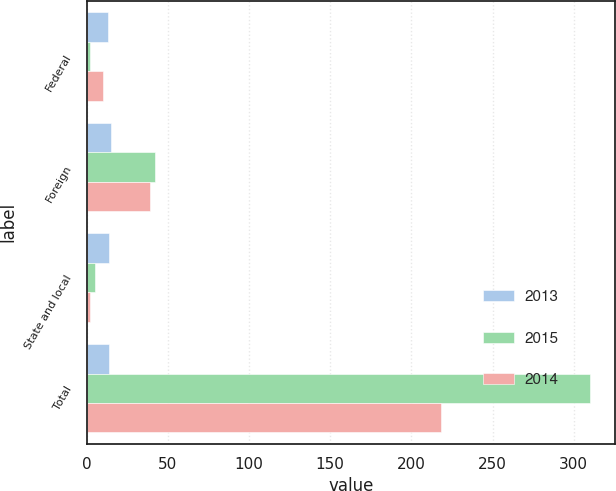<chart> <loc_0><loc_0><loc_500><loc_500><stacked_bar_chart><ecel><fcel>Federal<fcel>Foreign<fcel>State and local<fcel>Total<nl><fcel>2013<fcel>13<fcel>15<fcel>14<fcel>14<nl><fcel>2015<fcel>2<fcel>42<fcel>5<fcel>310<nl><fcel>2014<fcel>10<fcel>39<fcel>2<fcel>218<nl></chart> 